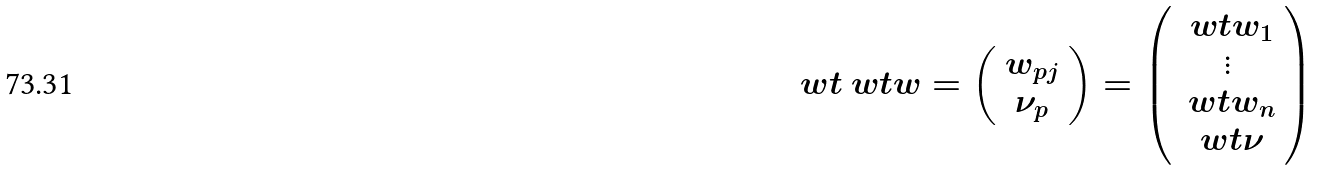Convert formula to latex. <formula><loc_0><loc_0><loc_500><loc_500>\ w t { \ w t { w } } = \left ( \begin{array} { c } { w } _ { p j } \\ \nu _ { p } \end{array} \right ) = \left ( \begin{array} { c } \ w t { w } _ { 1 } \\ \vdots \\ \ w t { w } _ { n } \\ \ w t { \nu } \end{array} \right )</formula> 